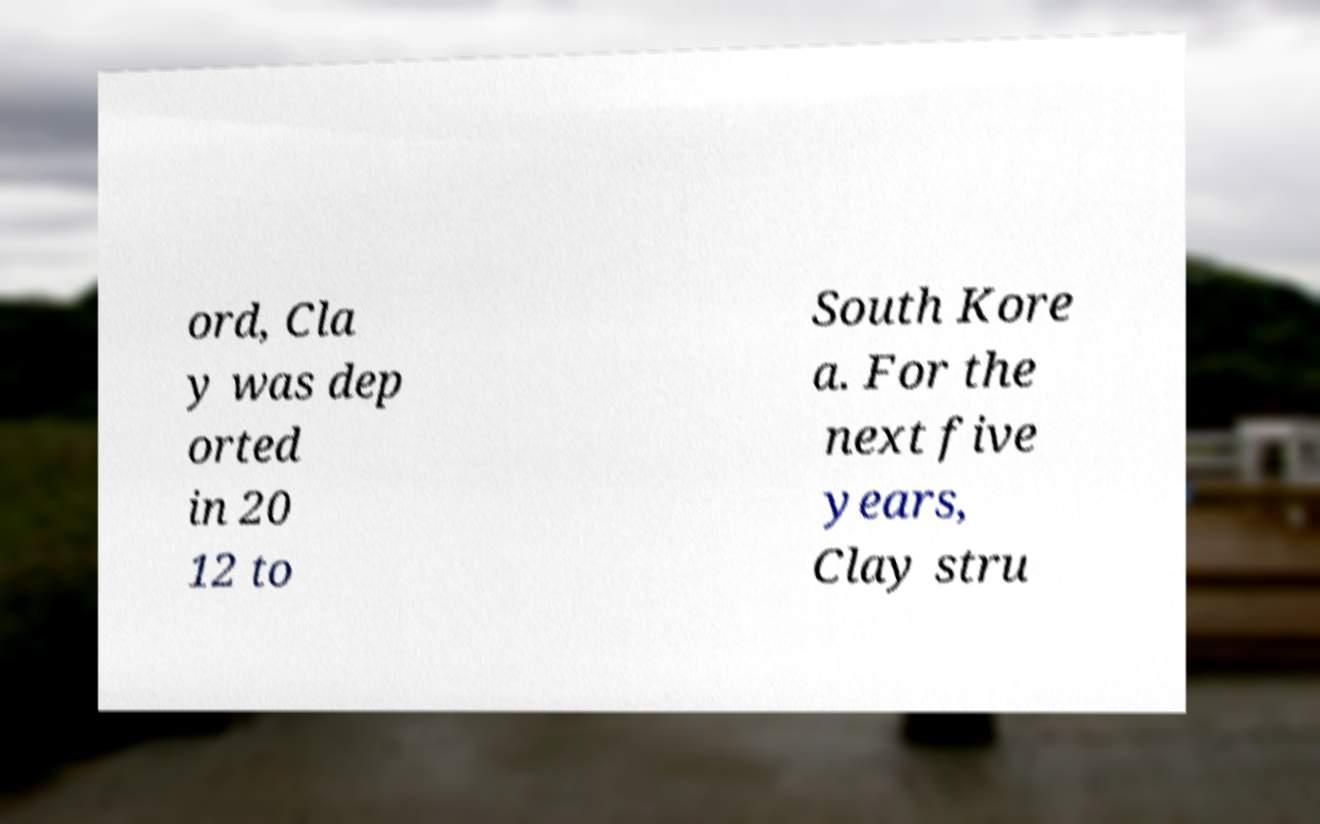Can you accurately transcribe the text from the provided image for me? ord, Cla y was dep orted in 20 12 to South Kore a. For the next five years, Clay stru 